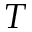Convert formula to latex. <formula><loc_0><loc_0><loc_500><loc_500>T</formula> 